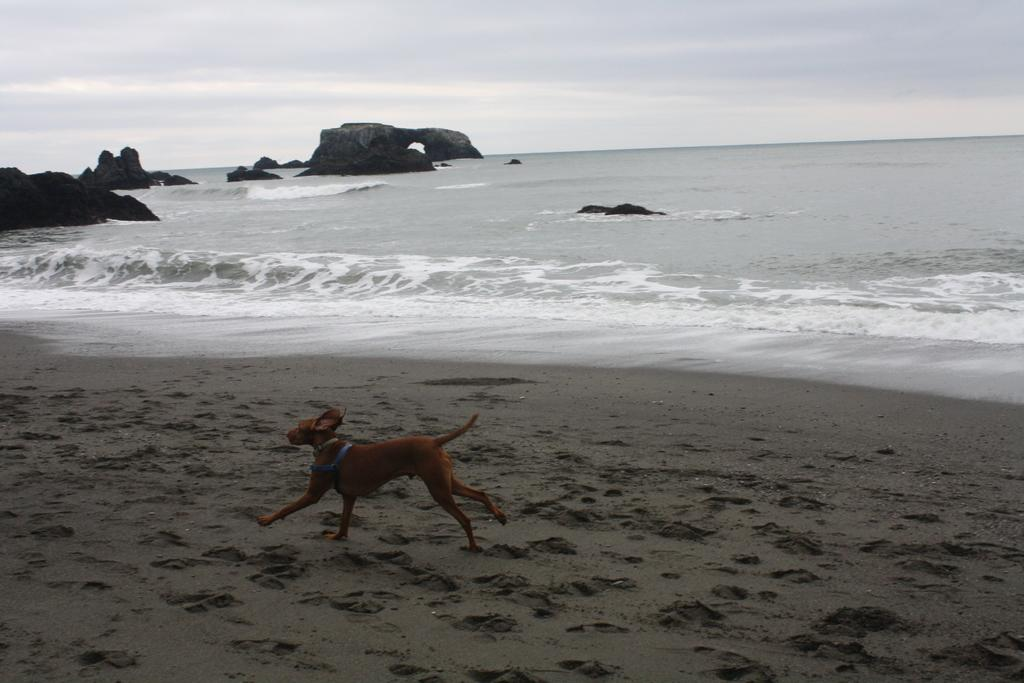What animal can be seen in the image? There is a dog in the image. What is the dog doing in the image? The dog is running on the ground. What natural element is visible in the image? There is water visible in the image. What type of terrain can be seen in the image? There are rocks in the image. What is visible above the ground in the image? The sky is visible in the image. What type of list is the dog holding in the image? There is no list present in the image; the dog is running on the ground. Can you see any crates in the image? There are no crates visible in the image. 